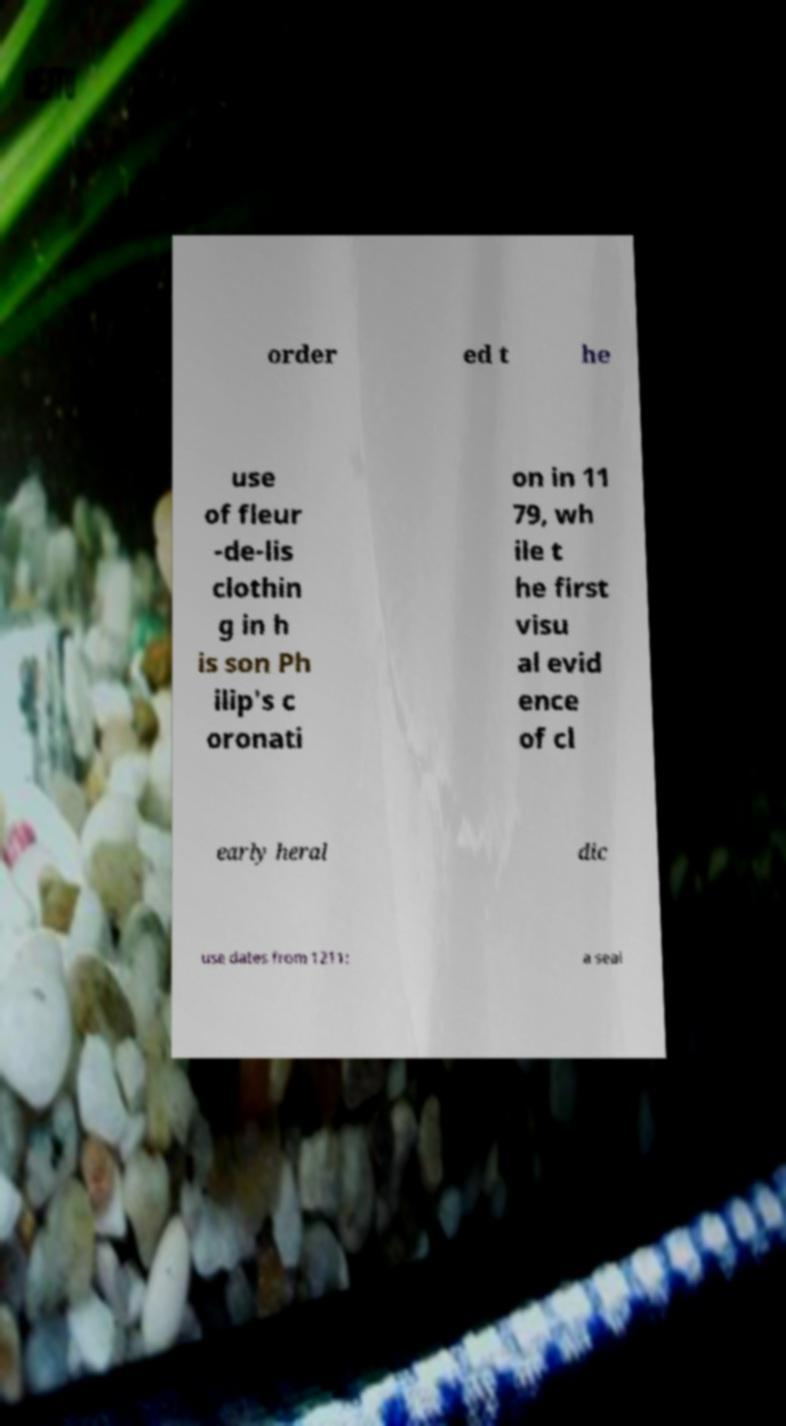Please read and relay the text visible in this image. What does it say? order ed t he use of fleur -de-lis clothin g in h is son Ph ilip's c oronati on in 11 79, wh ile t he first visu al evid ence of cl early heral dic use dates from 1211: a seal 